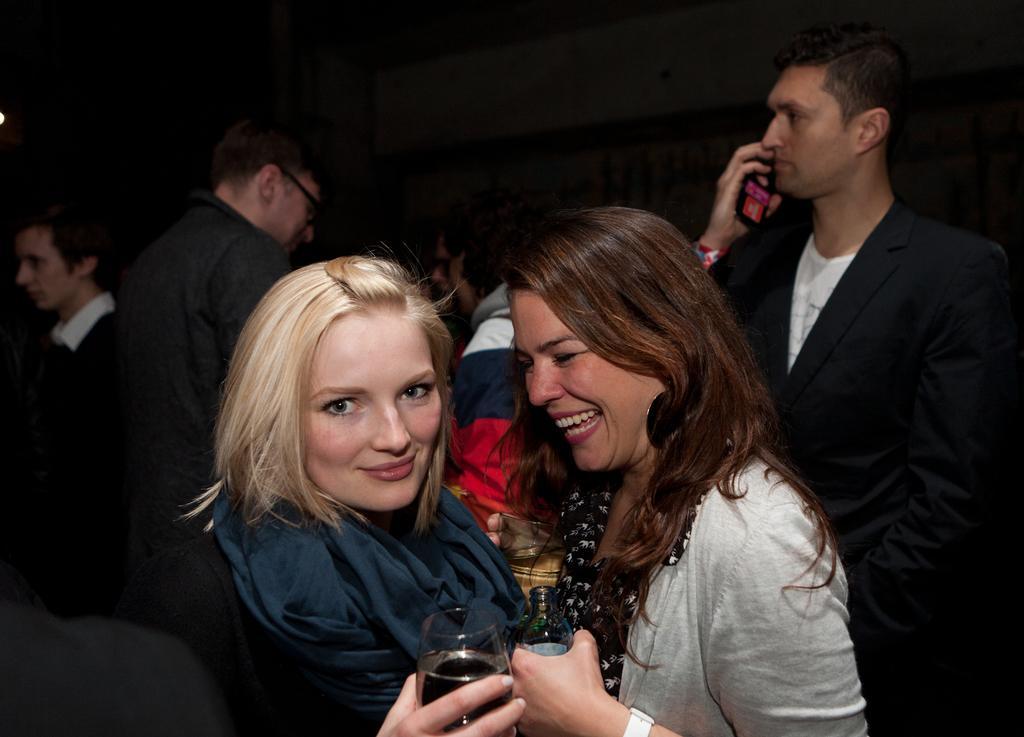Describe this image in one or two sentences. There are two women carrying a glass in their hands and there are group of people behind them. 